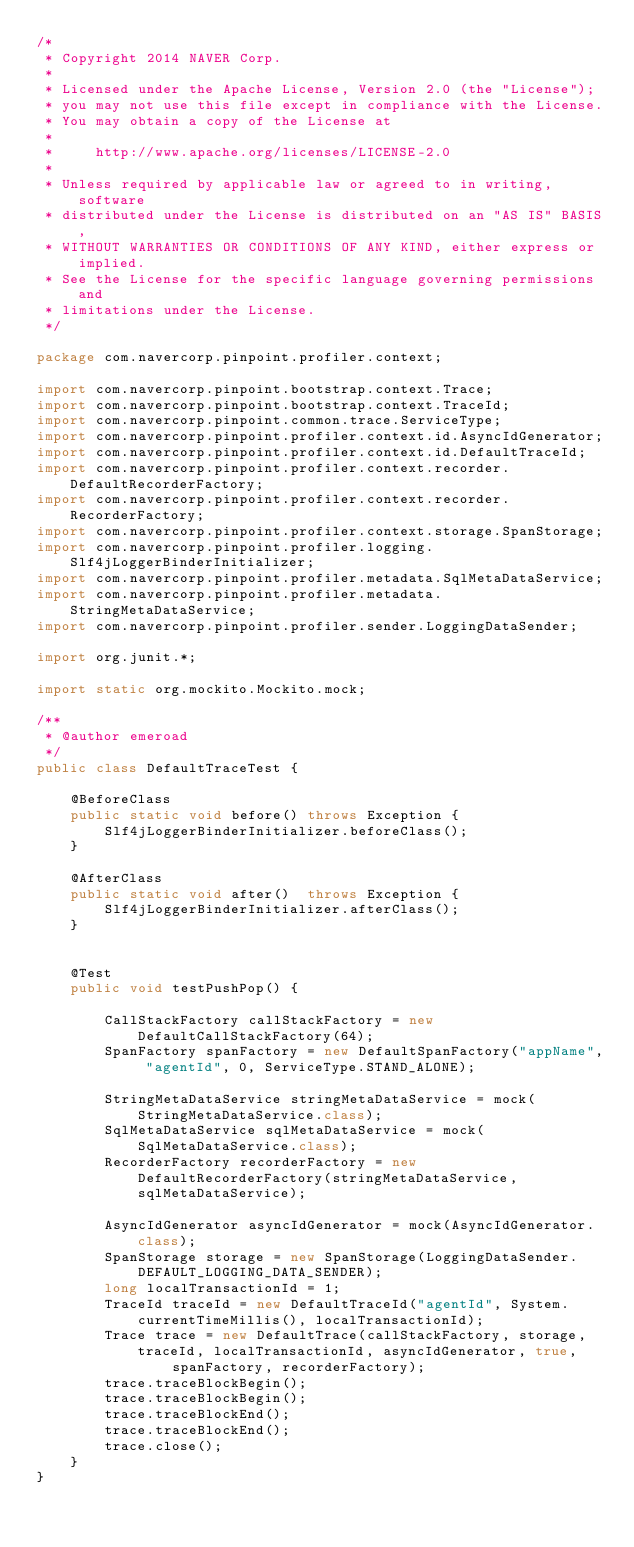<code> <loc_0><loc_0><loc_500><loc_500><_Java_>/*
 * Copyright 2014 NAVER Corp.
 *
 * Licensed under the Apache License, Version 2.0 (the "License");
 * you may not use this file except in compliance with the License.
 * You may obtain a copy of the License at
 *
 *     http://www.apache.org/licenses/LICENSE-2.0
 *
 * Unless required by applicable law or agreed to in writing, software
 * distributed under the License is distributed on an "AS IS" BASIS,
 * WITHOUT WARRANTIES OR CONDITIONS OF ANY KIND, either express or implied.
 * See the License for the specific language governing permissions and
 * limitations under the License.
 */

package com.navercorp.pinpoint.profiler.context;

import com.navercorp.pinpoint.bootstrap.context.Trace;
import com.navercorp.pinpoint.bootstrap.context.TraceId;
import com.navercorp.pinpoint.common.trace.ServiceType;
import com.navercorp.pinpoint.profiler.context.id.AsyncIdGenerator;
import com.navercorp.pinpoint.profiler.context.id.DefaultTraceId;
import com.navercorp.pinpoint.profiler.context.recorder.DefaultRecorderFactory;
import com.navercorp.pinpoint.profiler.context.recorder.RecorderFactory;
import com.navercorp.pinpoint.profiler.context.storage.SpanStorage;
import com.navercorp.pinpoint.profiler.logging.Slf4jLoggerBinderInitializer;
import com.navercorp.pinpoint.profiler.metadata.SqlMetaDataService;
import com.navercorp.pinpoint.profiler.metadata.StringMetaDataService;
import com.navercorp.pinpoint.profiler.sender.LoggingDataSender;

import org.junit.*;

import static org.mockito.Mockito.mock;

/**
 * @author emeroad
 */
public class DefaultTraceTest {

    @BeforeClass
    public static void before() throws Exception {
        Slf4jLoggerBinderInitializer.beforeClass();
    }

    @AfterClass
    public static void after()  throws Exception {
        Slf4jLoggerBinderInitializer.afterClass();
    }


    @Test
    public void testPushPop() {

        CallStackFactory callStackFactory = new DefaultCallStackFactory(64);
        SpanFactory spanFactory = new DefaultSpanFactory("appName", "agentId", 0, ServiceType.STAND_ALONE);

        StringMetaDataService stringMetaDataService = mock(StringMetaDataService.class);
        SqlMetaDataService sqlMetaDataService = mock(SqlMetaDataService.class);
        RecorderFactory recorderFactory = new DefaultRecorderFactory(stringMetaDataService, sqlMetaDataService);

        AsyncIdGenerator asyncIdGenerator = mock(AsyncIdGenerator.class);
        SpanStorage storage = new SpanStorage(LoggingDataSender.DEFAULT_LOGGING_DATA_SENDER);
        long localTransactionId = 1;
        TraceId traceId = new DefaultTraceId("agentId", System.currentTimeMillis(), localTransactionId);
        Trace trace = new DefaultTrace(callStackFactory, storage, traceId, localTransactionId, asyncIdGenerator, true,
                spanFactory, recorderFactory);
        trace.traceBlockBegin();
        trace.traceBlockBegin();
        trace.traceBlockEnd();
        trace.traceBlockEnd();
        trace.close();
    }
}
</code> 